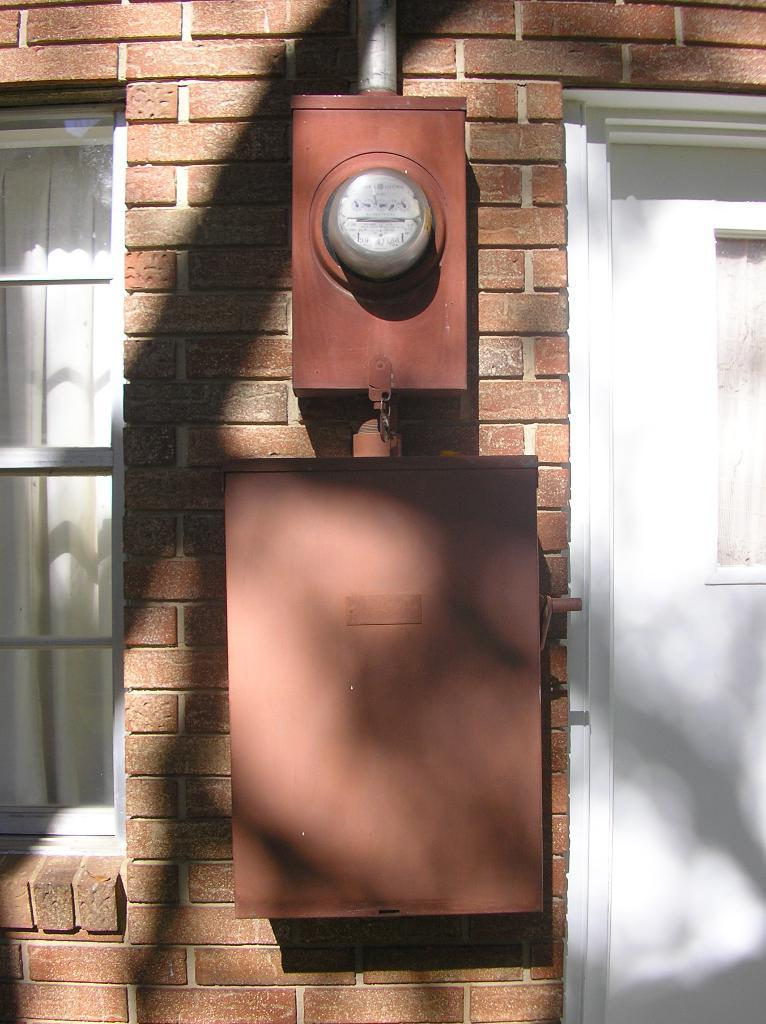What is attached to the brick wall in the image? There are two objects attached to a brick wall in the image. Can you describe any other features of the wall? There is a window in the image. What is the color of the door in the image? There is a white door in the image. How many cups of water are needed to fill the bucket in the image? There is no bucket present in the image. What time of day is depicted in the image? The time of day cannot be determined from the image, as there are no clues or indicators present. 